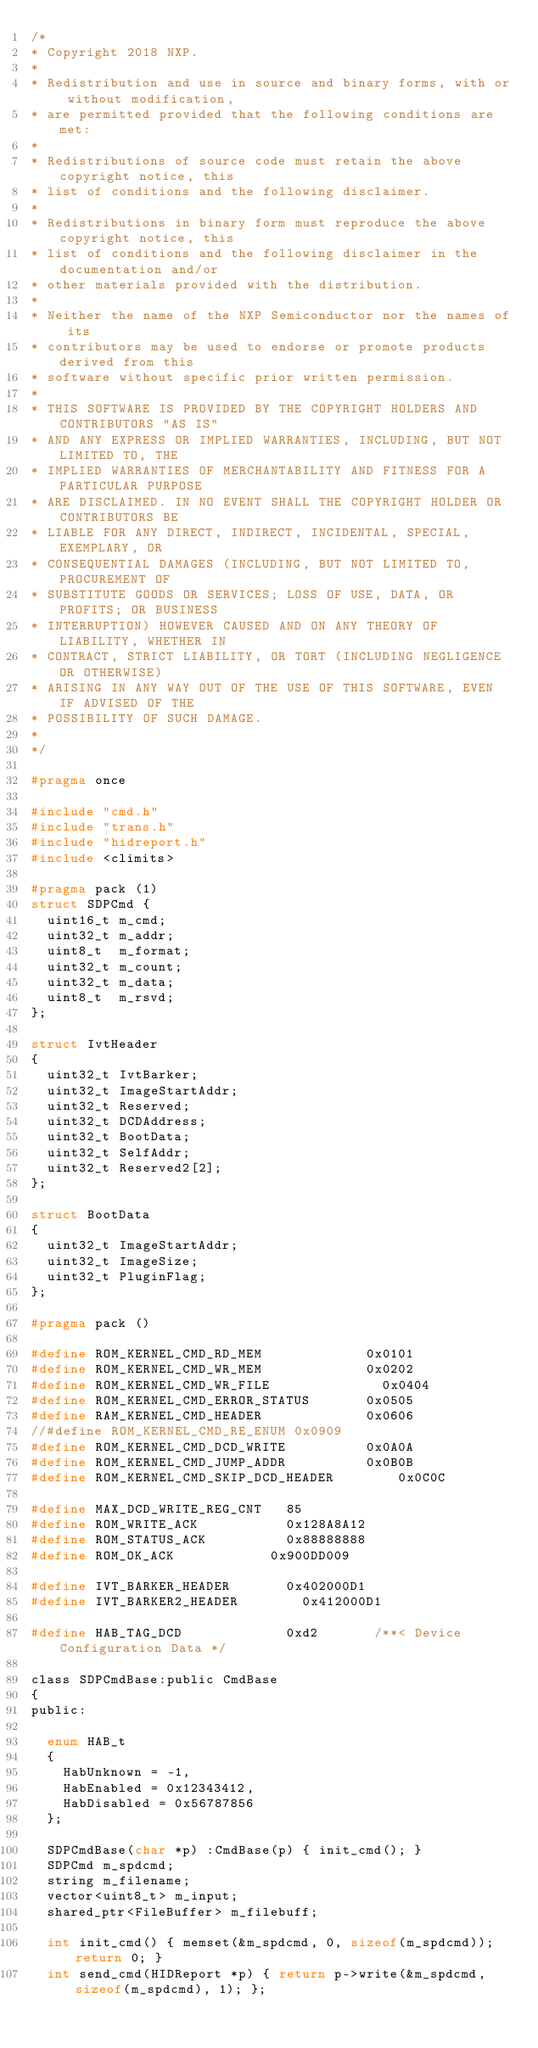<code> <loc_0><loc_0><loc_500><loc_500><_C_>/*
* Copyright 2018 NXP.
*
* Redistribution and use in source and binary forms, with or without modification,
* are permitted provided that the following conditions are met:
*
* Redistributions of source code must retain the above copyright notice, this
* list of conditions and the following disclaimer.
*
* Redistributions in binary form must reproduce the above copyright notice, this
* list of conditions and the following disclaimer in the documentation and/or
* other materials provided with the distribution.
*
* Neither the name of the NXP Semiconductor nor the names of its
* contributors may be used to endorse or promote products derived from this
* software without specific prior written permission.
*
* THIS SOFTWARE IS PROVIDED BY THE COPYRIGHT HOLDERS AND CONTRIBUTORS "AS IS"
* AND ANY EXPRESS OR IMPLIED WARRANTIES, INCLUDING, BUT NOT LIMITED TO, THE
* IMPLIED WARRANTIES OF MERCHANTABILITY AND FITNESS FOR A PARTICULAR PURPOSE
* ARE DISCLAIMED. IN NO EVENT SHALL THE COPYRIGHT HOLDER OR CONTRIBUTORS BE
* LIABLE FOR ANY DIRECT, INDIRECT, INCIDENTAL, SPECIAL, EXEMPLARY, OR
* CONSEQUENTIAL DAMAGES (INCLUDING, BUT NOT LIMITED TO, PROCUREMENT OF
* SUBSTITUTE GOODS OR SERVICES; LOSS OF USE, DATA, OR PROFITS; OR BUSINESS
* INTERRUPTION) HOWEVER CAUSED AND ON ANY THEORY OF LIABILITY, WHETHER IN
* CONTRACT, STRICT LIABILITY, OR TORT (INCLUDING NEGLIGENCE OR OTHERWISE)
* ARISING IN ANY WAY OUT OF THE USE OF THIS SOFTWARE, EVEN IF ADVISED OF THE
* POSSIBILITY OF SUCH DAMAGE.
*
*/

#pragma once

#include "cmd.h"
#include "trans.h"
#include "hidreport.h"
#include <climits>

#pragma pack (1)
struct SDPCmd {
	uint16_t m_cmd;
	uint32_t m_addr;
	uint8_t  m_format;
	uint32_t m_count;
	uint32_t m_data;
	uint8_t  m_rsvd;
};

struct IvtHeader
{
	uint32_t IvtBarker;
	uint32_t ImageStartAddr;
	uint32_t Reserved;
	uint32_t DCDAddress;
	uint32_t BootData;
	uint32_t SelfAddr;
	uint32_t Reserved2[2];
};

struct BootData
{
	uint32_t ImageStartAddr;
	uint32_t ImageSize;
	uint32_t PluginFlag;
};

#pragma pack ()

#define ROM_KERNEL_CMD_RD_MEM							0x0101
#define ROM_KERNEL_CMD_WR_MEM							0x0202
#define ROM_KERNEL_CMD_WR_FILE							0x0404
#define ROM_KERNEL_CMD_ERROR_STATUS				0x0505
#define RAM_KERNEL_CMD_HEADER							0x0606
//#define ROM_KERNEL_CMD_RE_ENUM 0x0909
#define ROM_KERNEL_CMD_DCD_WRITE					0x0A0A
#define ROM_KERNEL_CMD_JUMP_ADDR					0x0B0B
#define ROM_KERNEL_CMD_SKIP_DCD_HEADER				0x0C0C

#define MAX_DCD_WRITE_REG_CNT		85
#define ROM_WRITE_ACK						0x128A8A12
#define ROM_STATUS_ACK					0x88888888
#define ROM_OK_ACK						0x900DD009

#define IVT_BARKER_HEADER				0x402000D1
#define IVT_BARKER2_HEADER				0x412000D1

#define HAB_TAG_DCD							0xd2       /**< Device Configuration Data */

class SDPCmdBase:public CmdBase
{
public:

	enum HAB_t
	{
		HabUnknown = -1,
		HabEnabled = 0x12343412,
		HabDisabled = 0x56787856
	};

	SDPCmdBase(char *p) :CmdBase(p) { init_cmd(); }
	SDPCmd m_spdcmd;
	string m_filename;
	vector<uint8_t> m_input;
	shared_ptr<FileBuffer> m_filebuff;

	int init_cmd() { memset(&m_spdcmd, 0, sizeof(m_spdcmd)); return 0; }
	int send_cmd(HIDReport *p) { return p->write(&m_spdcmd, sizeof(m_spdcmd), 1); };</code> 